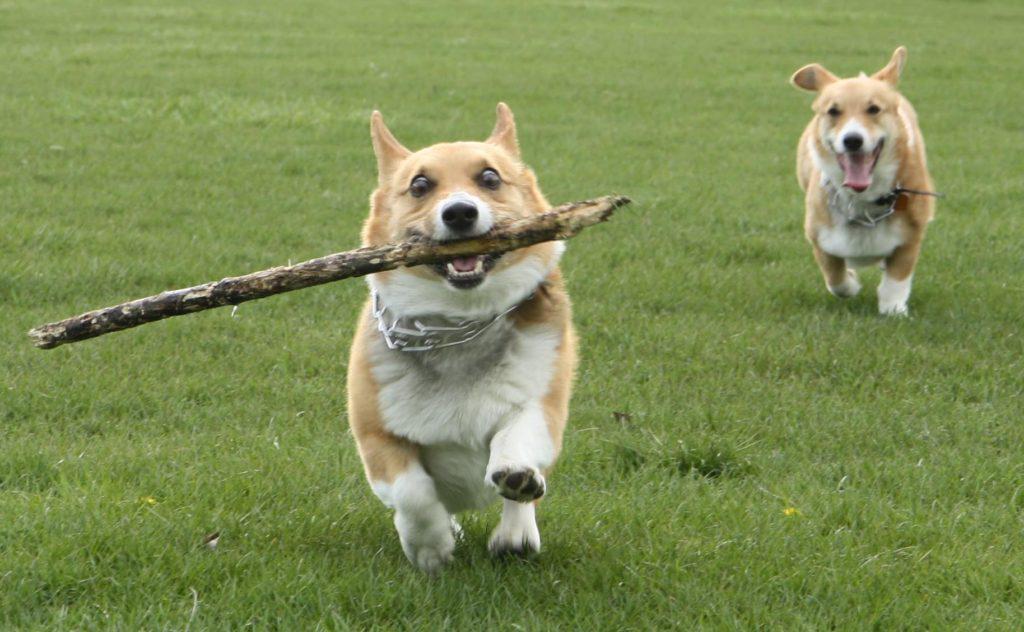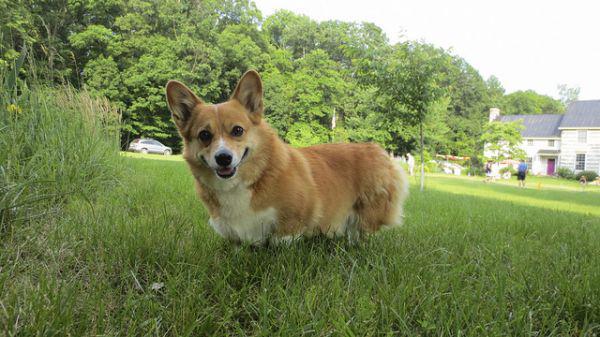The first image is the image on the left, the second image is the image on the right. Considering the images on both sides, is "In one of the images there is a single corgi sitting on the ground outside." valid? Answer yes or no. No. The first image is the image on the left, the second image is the image on the right. Considering the images on both sides, is "Each image shows exactly one corgi dog outdoors on grass." valid? Answer yes or no. No. The first image is the image on the left, the second image is the image on the right. Evaluate the accuracy of this statement regarding the images: "Neither dog is walking or running.". Is it true? Answer yes or no. No. 